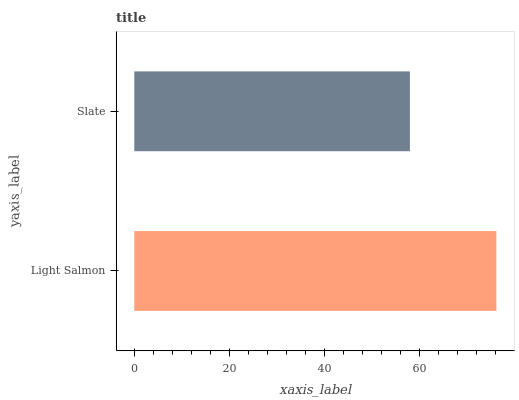Is Slate the minimum?
Answer yes or no. Yes. Is Light Salmon the maximum?
Answer yes or no. Yes. Is Slate the maximum?
Answer yes or no. No. Is Light Salmon greater than Slate?
Answer yes or no. Yes. Is Slate less than Light Salmon?
Answer yes or no. Yes. Is Slate greater than Light Salmon?
Answer yes or no. No. Is Light Salmon less than Slate?
Answer yes or no. No. Is Light Salmon the high median?
Answer yes or no. Yes. Is Slate the low median?
Answer yes or no. Yes. Is Slate the high median?
Answer yes or no. No. Is Light Salmon the low median?
Answer yes or no. No. 